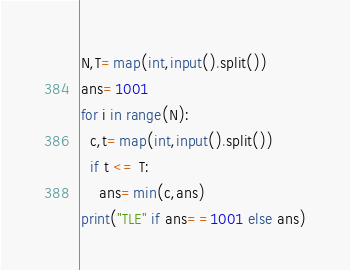<code> <loc_0><loc_0><loc_500><loc_500><_Python_>N,T=map(int,input().split())
ans=1001
for i in range(N):
  c,t=map(int,input().split())
  if t <= T:
    ans=min(c,ans)
print("TLE" if ans==1001 else ans)</code> 